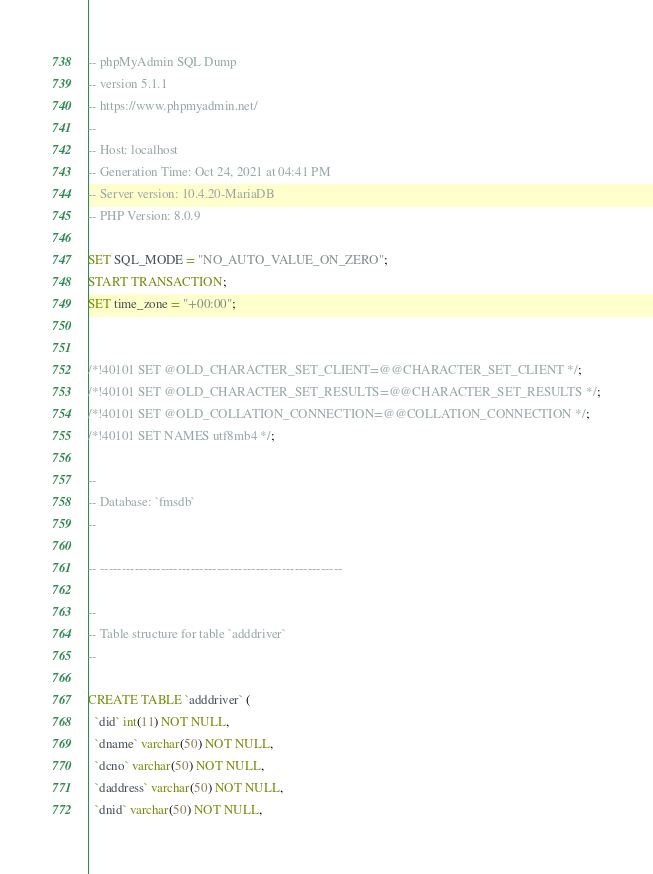Convert code to text. <code><loc_0><loc_0><loc_500><loc_500><_SQL_>-- phpMyAdmin SQL Dump
-- version 5.1.1
-- https://www.phpmyadmin.net/
--
-- Host: localhost
-- Generation Time: Oct 24, 2021 at 04:41 PM
-- Server version: 10.4.20-MariaDB
-- PHP Version: 8.0.9

SET SQL_MODE = "NO_AUTO_VALUE_ON_ZERO";
START TRANSACTION;
SET time_zone = "+00:00";


/*!40101 SET @OLD_CHARACTER_SET_CLIENT=@@CHARACTER_SET_CLIENT */;
/*!40101 SET @OLD_CHARACTER_SET_RESULTS=@@CHARACTER_SET_RESULTS */;
/*!40101 SET @OLD_COLLATION_CONNECTION=@@COLLATION_CONNECTION */;
/*!40101 SET NAMES utf8mb4 */;

--
-- Database: `fmsdb`
--

-- --------------------------------------------------------

--
-- Table structure for table `adddriver`
--

CREATE TABLE `adddriver` (
  `did` int(11) NOT NULL,
  `dname` varchar(50) NOT NULL,
  `dcno` varchar(50) NOT NULL,
  `daddress` varchar(50) NOT NULL,
  `dnid` varchar(50) NOT NULL,</code> 